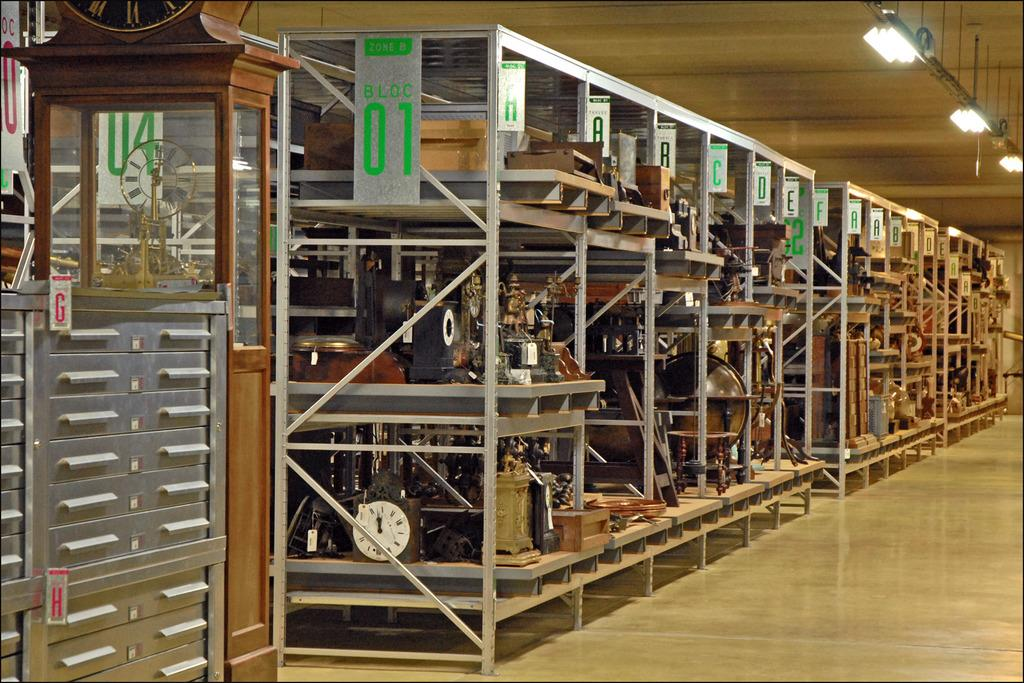<image>
Write a terse but informative summary of the picture. Warehouse with aisles of antiques and says "BLOC 01". 